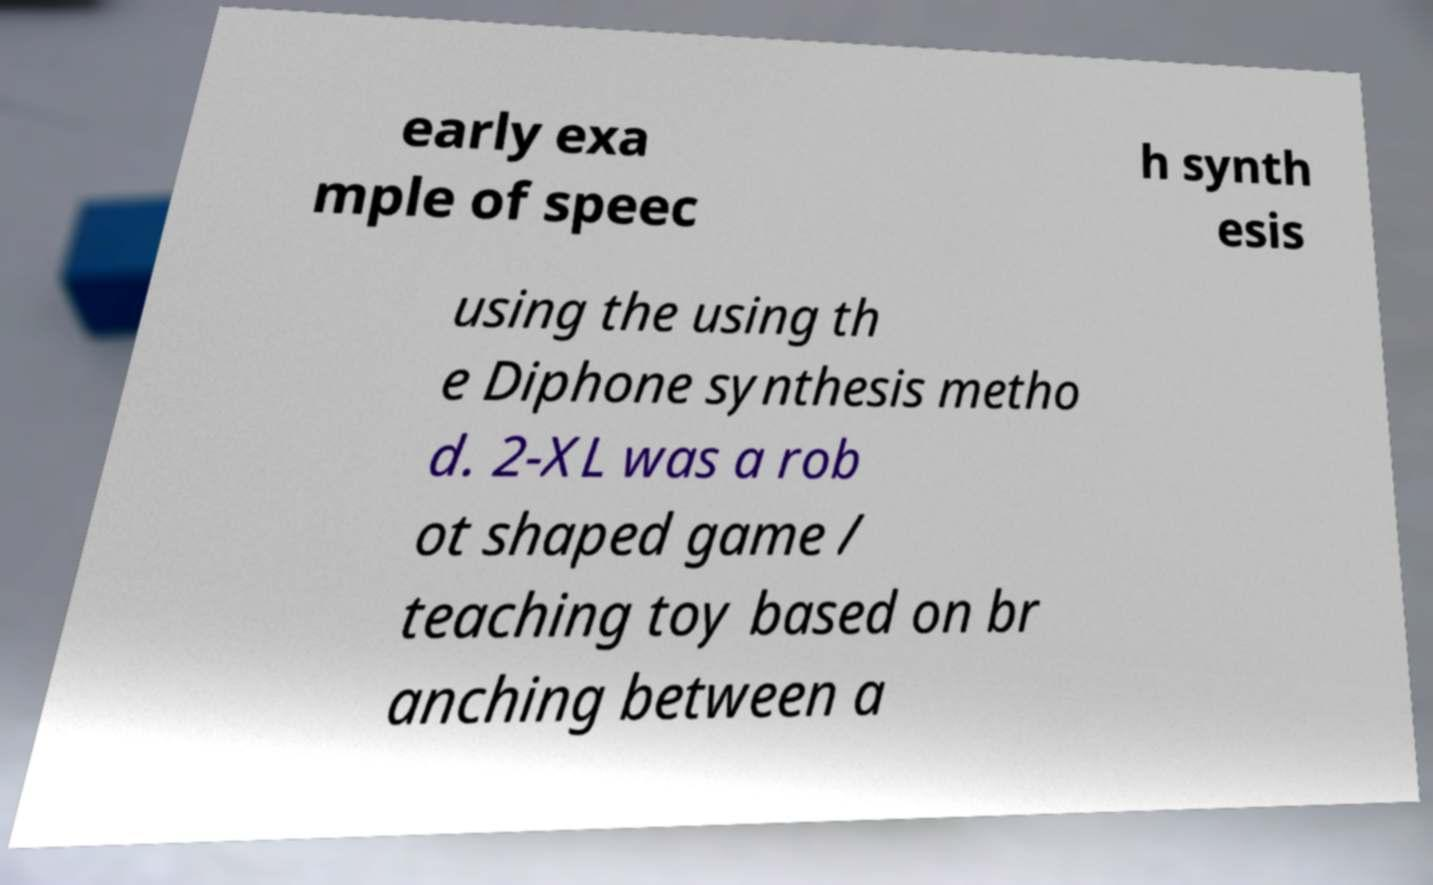There's text embedded in this image that I need extracted. Can you transcribe it verbatim? early exa mple of speec h synth esis using the using th e Diphone synthesis metho d. 2-XL was a rob ot shaped game / teaching toy based on br anching between a 